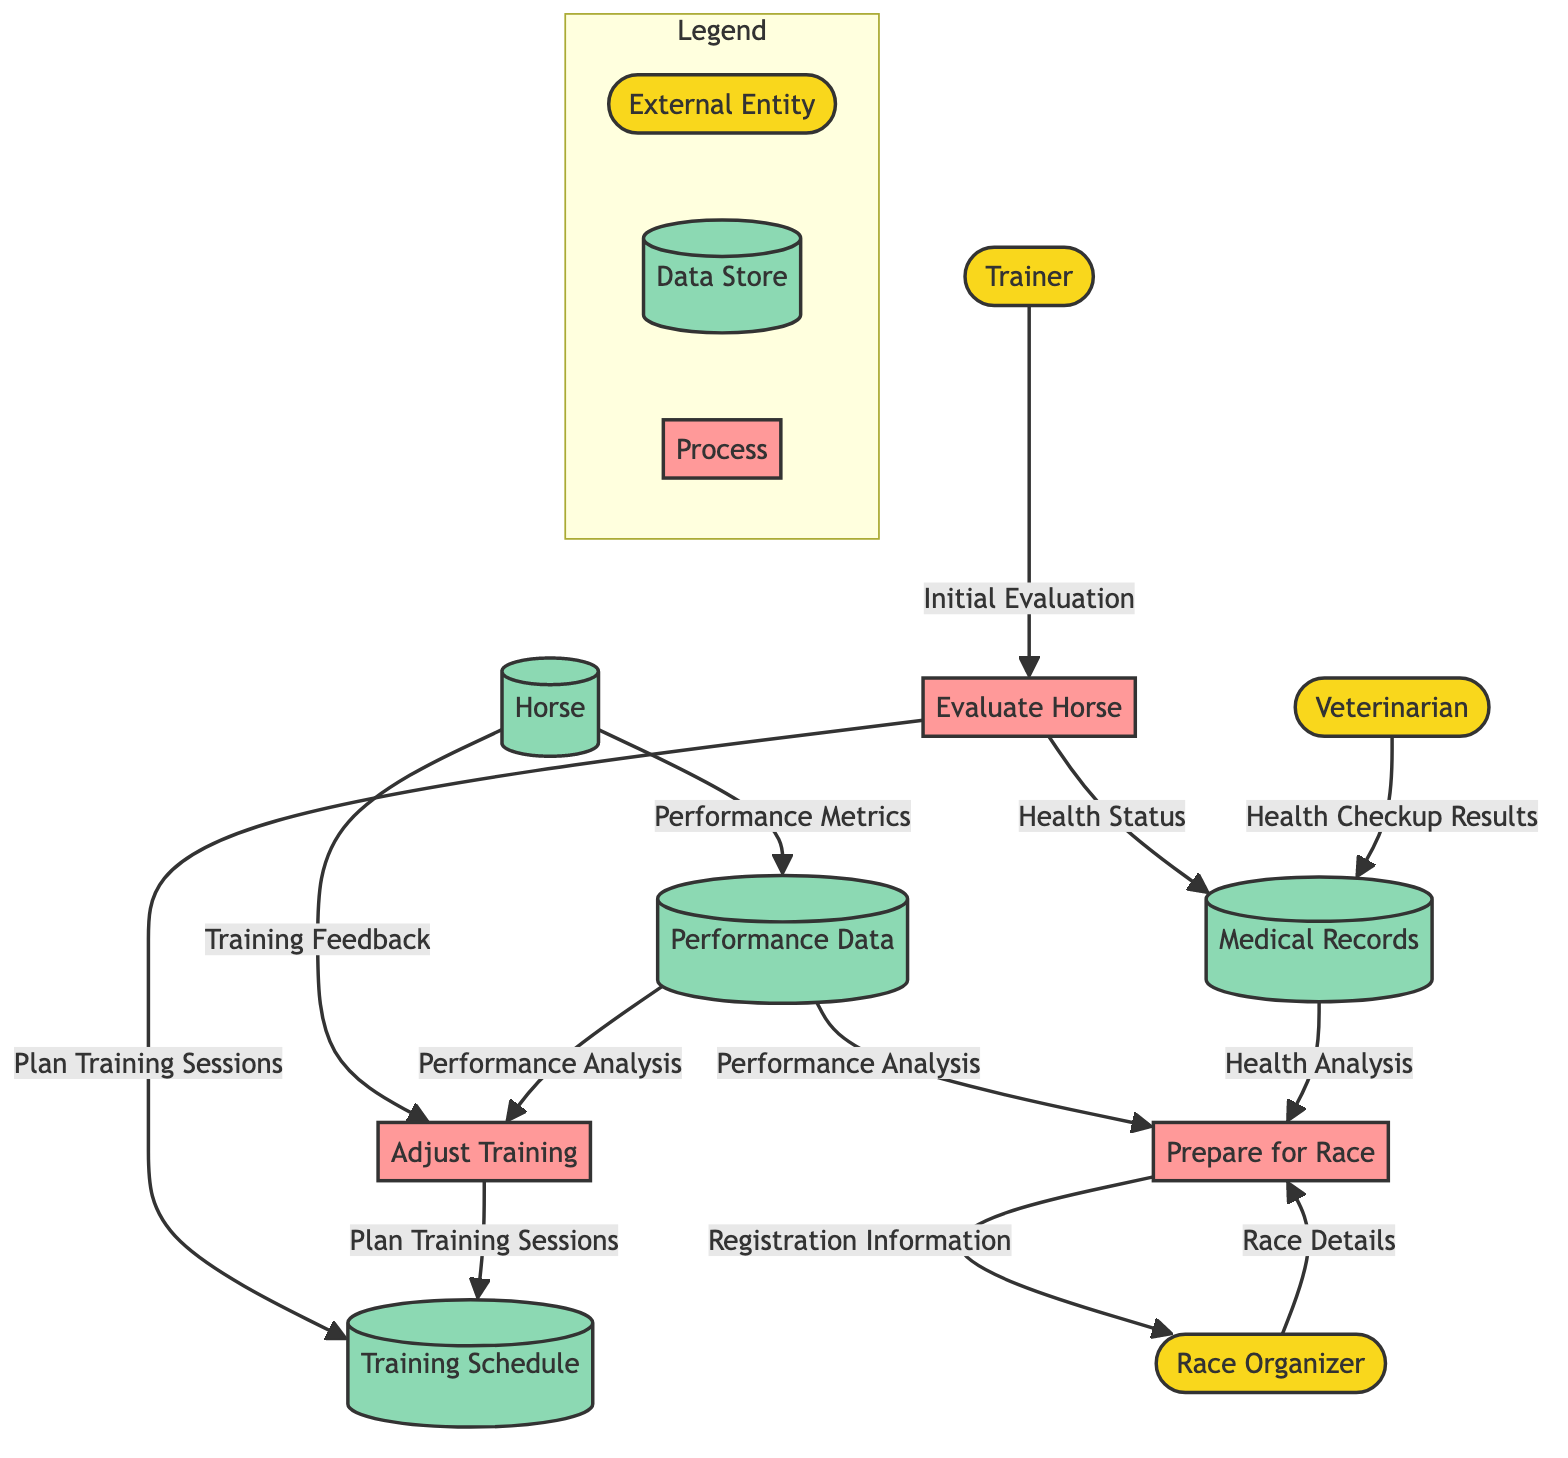What entities are included in the diagram? The diagram includes six entities: Trainer, Horse, Race Organizer, Training Schedule, Medical Records, and Veterinarian.
Answer: Trainer, Horse, Race Organizer, Training Schedule, Medical Records, Veterinarian How many processes are depicted in the diagram? There are three processes shown: Evaluate Horse, Adjust Training, and Prepare for Race. The count is obtained by directly identifying the processes listed in the diagram.
Answer: 3 What data flows from the Trainer to the Race Organizer? The data flow from the Trainer to the Race Organizer includes Registration Information. This is indicated in the flow connection between these two entities.
Answer: Registration Information Which data store receives the Health Checkup Results? Medical Records is the data store that receives Health Checkup Results from the Veterinarian, as indicated in the data flow connection between them.
Answer: Medical Records What is the output of the Evaluate Horse process? The outputs of the Evaluate Horse process are Plan Training Sessions and Health Status. These outputs can be directly identified in the process' output section.
Answer: Plan Training Sessions, Health Status Which external entity provides the Race Details? The Race Organizer provides Race Details to the Prepare for Race process. This can be found in the flow that connects the Race Organizer to the process.
Answer: Race Organizer What inputs does the Adjust Training process require? Adjust Training requires two inputs: Training Feedback and Performance Analysis. This information can be found in the inputs section of the Adjust Training process in the diagram.
Answer: Training Feedback, Performance Analysis How does Performance Data flow to the Trainer? Performance Data flows to the Trainer as Performance Analysis. The flow establishes a connection from Performance Data directly to the Trainer indicating the type of information transmitted.
Answer: Performance Analysis 